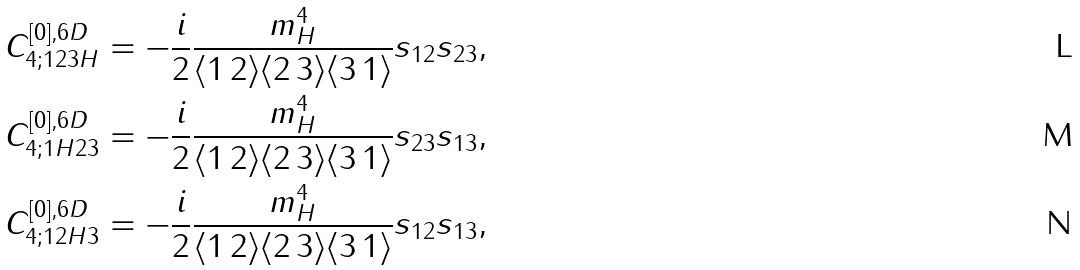<formula> <loc_0><loc_0><loc_500><loc_500>C _ { 4 ; 1 2 3 H } ^ { [ 0 ] , 6 D } & = - \frac { i } { 2 } \frac { m _ { H } ^ { 4 } } { \langle 1 \, 2 \rangle \langle 2 \, 3 \rangle \langle 3 \, 1 \rangle } s _ { 1 2 } s _ { 2 3 } , \\ C _ { 4 ; 1 H 2 3 } ^ { [ 0 ] , 6 D } & = - \frac { i } { 2 } \frac { m _ { H } ^ { 4 } } { \langle 1 \, 2 \rangle \langle 2 \, 3 \rangle \langle 3 \, 1 \rangle } s _ { 2 3 } s _ { 1 3 } , \\ C _ { 4 ; 1 2 H 3 } ^ { [ 0 ] , 6 D } & = - \frac { i } { 2 } \frac { m _ { H } ^ { 4 } } { \langle 1 \, 2 \rangle \langle 2 \, 3 \rangle \langle 3 \, 1 \rangle } s _ { 1 2 } s _ { 1 3 } ,</formula> 